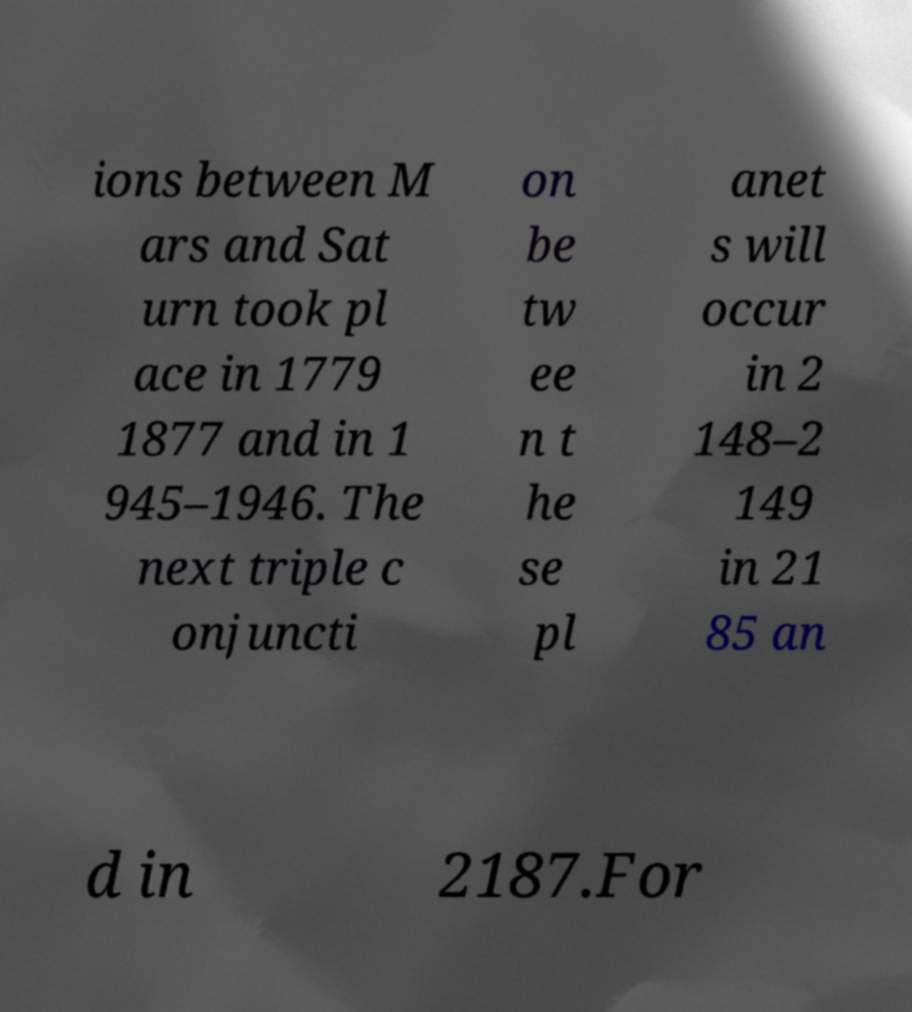Please read and relay the text visible in this image. What does it say? ions between M ars and Sat urn took pl ace in 1779 1877 and in 1 945–1946. The next triple c onjuncti on be tw ee n t he se pl anet s will occur in 2 148–2 149 in 21 85 an d in 2187.For 